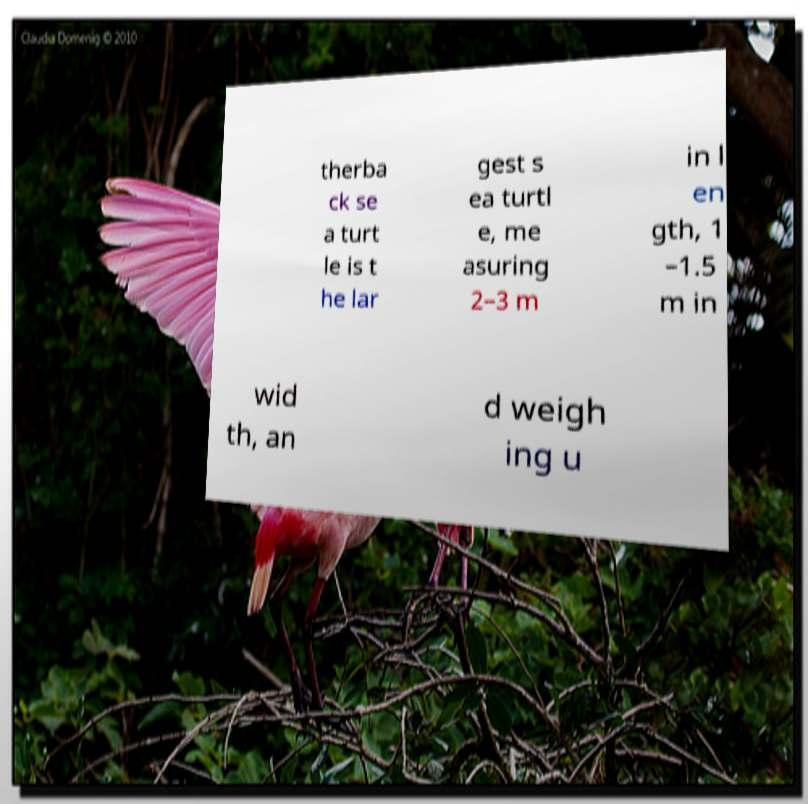Can you accurately transcribe the text from the provided image for me? therba ck se a turt le is t he lar gest s ea turtl e, me asuring 2–3 m in l en gth, 1 –1.5 m in wid th, an d weigh ing u 